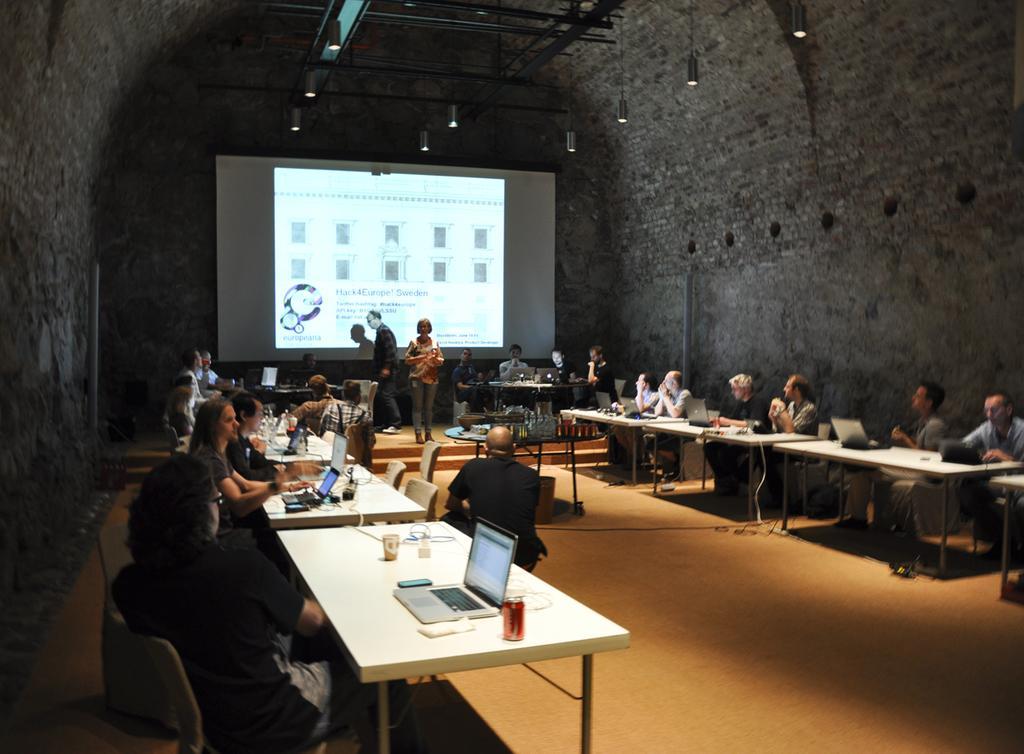How would you summarize this image in a sentence or two? In the image we can see there are many people sitting on chair and two of them are standing. There are many chairs and table in the room. On the table there is a laptop and a glass kept. This is a projected screen, this are the lights. 